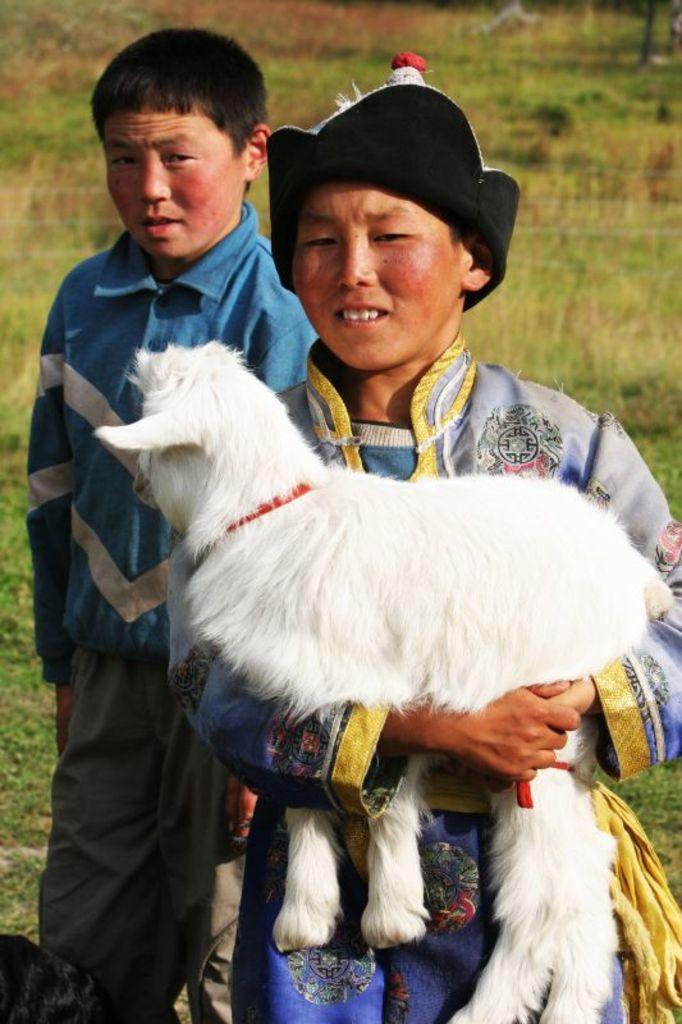Describe this image in one or two sentences. This image consists of two persons. One is holding a dog, which is in white color. There is grass in this image. 